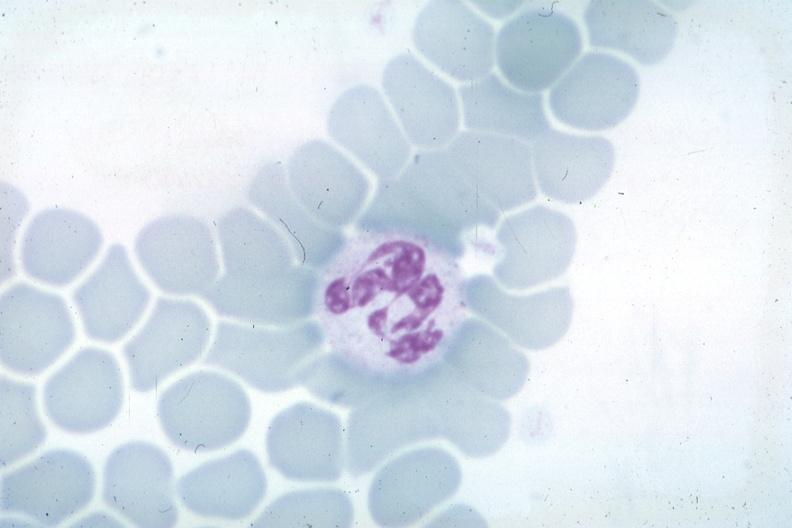what is present?
Answer the question using a single word or phrase. Hematologic 